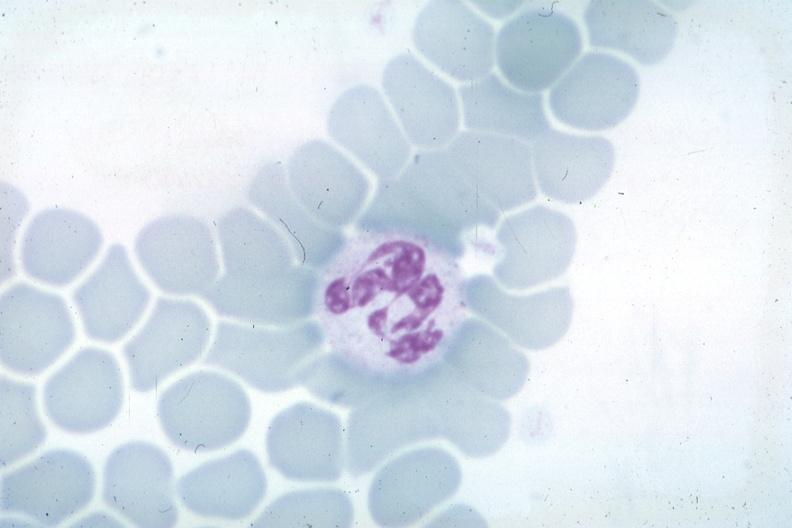what is present?
Answer the question using a single word or phrase. Hematologic 